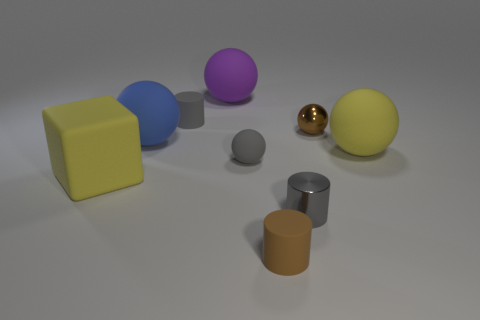There is a cube that is the same size as the purple matte ball; what is its material?
Your answer should be very brief. Rubber. Are there fewer gray shiny cylinders that are behind the small brown metallic object than brown metal things?
Your answer should be compact. Yes. There is a shiny thing behind the large yellow sphere that is on the right side of the cylinder that is behind the shiny cylinder; what is its shape?
Offer a terse response. Sphere. What size is the gray object that is behind the gray sphere?
Offer a terse response. Small. There is a gray matte object that is the same size as the gray sphere; what shape is it?
Your answer should be very brief. Cylinder. What number of things are either large purple things or tiny things in front of the yellow sphere?
Provide a short and direct response. 4. There is a sphere in front of the big matte ball that is to the right of the brown ball; how many tiny metal things are on the left side of it?
Provide a succinct answer. 0. There is another cylinder that is made of the same material as the small brown cylinder; what is its color?
Provide a short and direct response. Gray. Is the size of the gray thing that is to the left of the purple object the same as the yellow rubber sphere?
Keep it short and to the point. No. What number of things are either small brown rubber cylinders or tiny blue matte things?
Give a very brief answer. 1. 